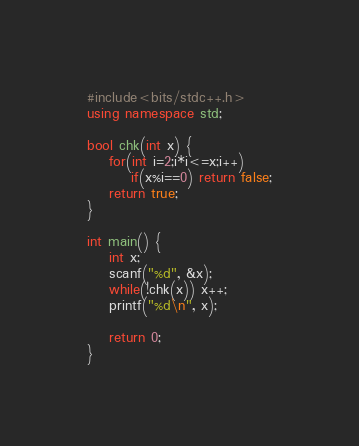Convert code to text. <code><loc_0><loc_0><loc_500><loc_500><_C++_>#include<bits/stdc++.h>
using namespace std;

bool chk(int x) {
	for(int i=2;i*i<=x;i++)
		if(x%i==0) return false;
	return true;
}

int main() {
	int x;
	scanf("%d", &x);
	while(!chk(x)) x++;
	printf("%d\n", x);
	
	return 0;
}</code> 